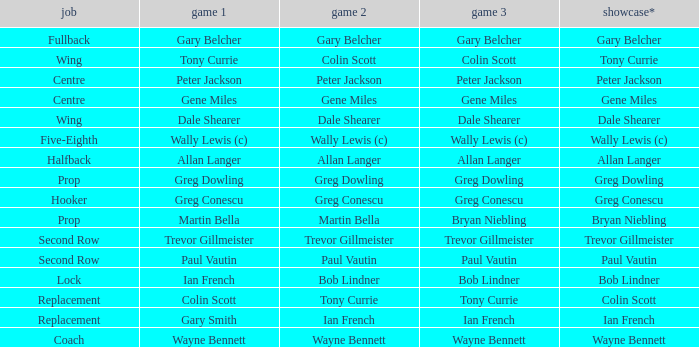What exhibition has greg conescu as game 1? Greg Conescu. 